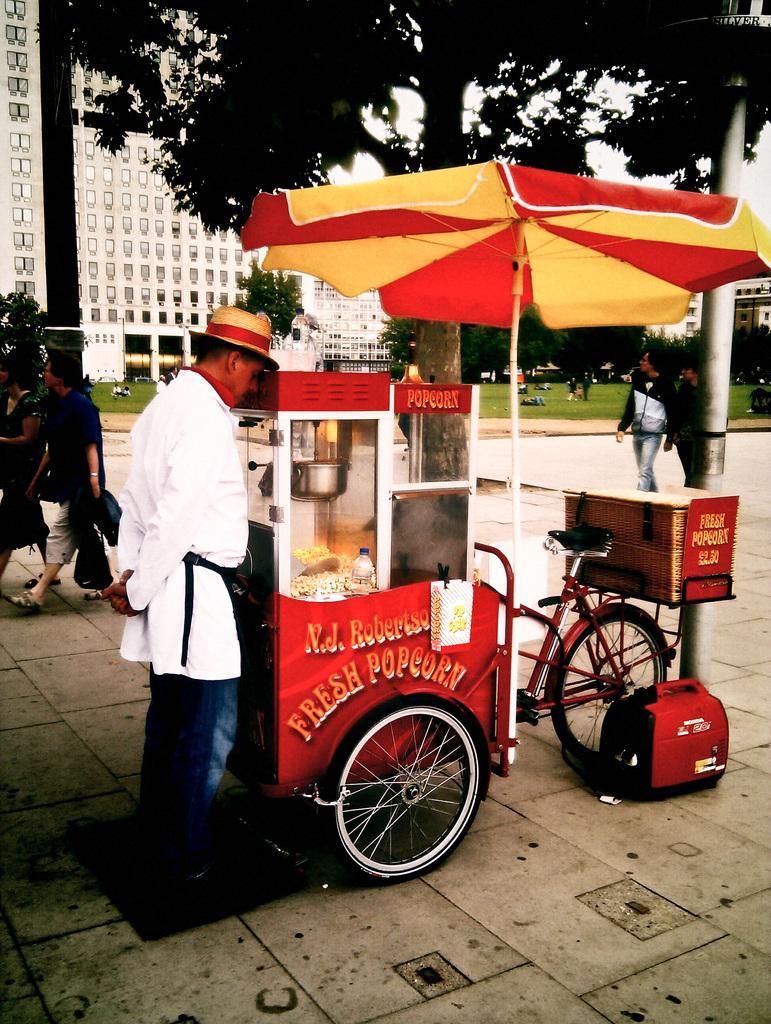Could you give a brief overview of what you see in this image? In this image we can see a popcorn bike. On the left there is a man standing and there are people walking. In the background there are buildings, trees and sky. 